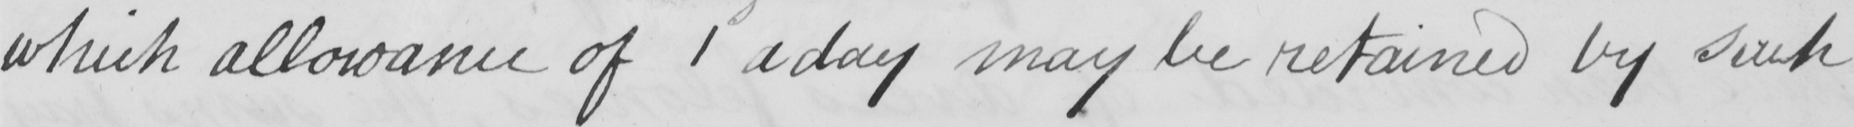What is written in this line of handwriting? which allowance of 1 a day may be retained by such 